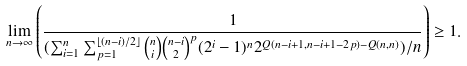<formula> <loc_0><loc_0><loc_500><loc_500>\lim _ { n \to \infty } \left ( \frac { 1 } { ( \sum _ { i = 1 } ^ { n } \sum _ { p = 1 } ^ { \lfloor ( n - i ) / 2 \rfloor } \binom { n } { i } \binom { n - i } { 2 } ^ { p } ( 2 ^ { i } - 1 ) ^ { n } 2 ^ { Q ( n - i + 1 , n - i + 1 - 2 p ) - Q ( n , n ) } ) / n } \right ) \geq 1 .</formula> 